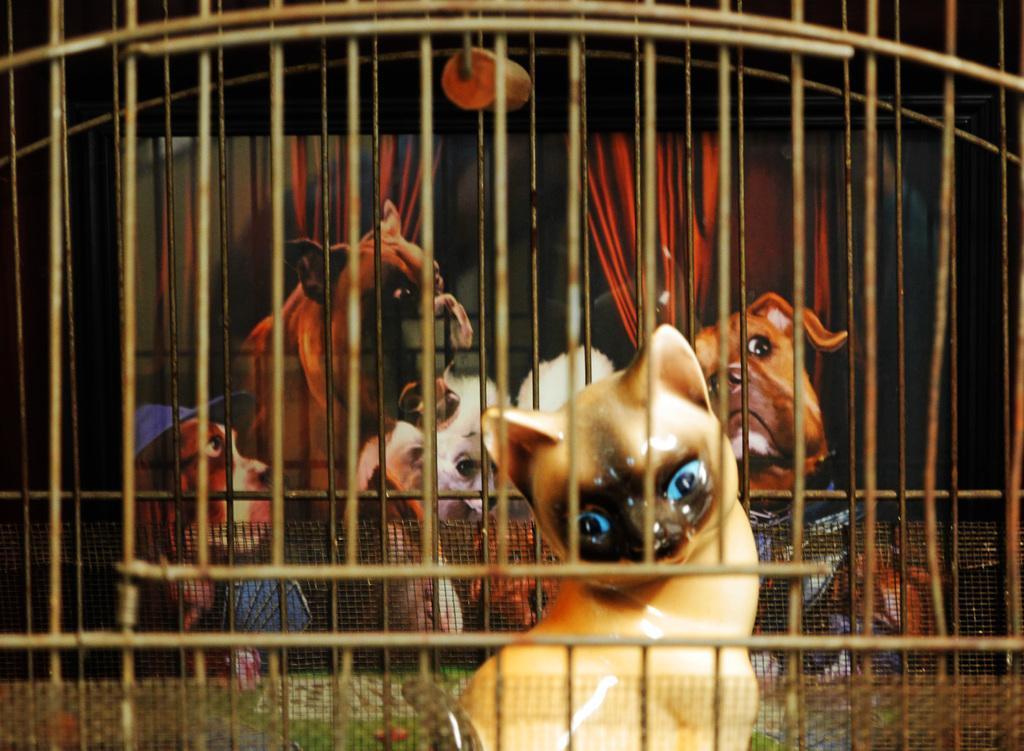How would you summarize this image in a sentence or two? In this picture, it looks like a cage and mesh. In the cage there is a toy. Behind the toy, there are animals in a photo frame. 